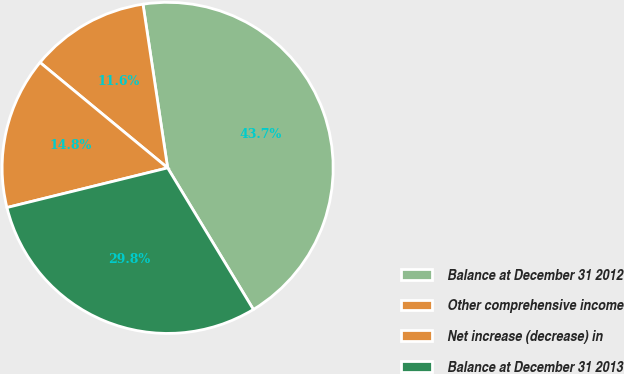Convert chart. <chart><loc_0><loc_0><loc_500><loc_500><pie_chart><fcel>Balance at December 31 2012<fcel>Other comprehensive income<fcel>Net increase (decrease) in<fcel>Balance at December 31 2013<nl><fcel>43.71%<fcel>11.63%<fcel>14.84%<fcel>29.81%<nl></chart> 